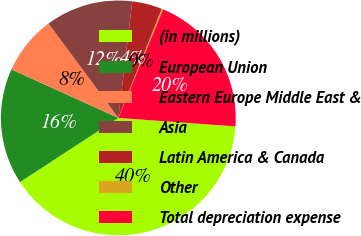Convert chart to OTSL. <chart><loc_0><loc_0><loc_500><loc_500><pie_chart><fcel>(in millions)<fcel>European Union<fcel>Eastern Europe Middle East &<fcel>Asia<fcel>Latin America & Canada<fcel>Other<fcel>Total depreciation expense<nl><fcel>39.65%<fcel>15.98%<fcel>8.09%<fcel>12.03%<fcel>4.14%<fcel>0.2%<fcel>19.92%<nl></chart> 